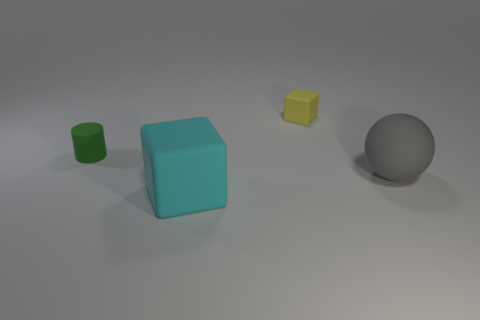Add 2 cyan cubes. How many objects exist? 6 Subtract all cylinders. How many objects are left? 3 Add 4 yellow matte cubes. How many yellow matte cubes exist? 5 Subtract 0 blue cylinders. How many objects are left? 4 Subtract all small blocks. Subtract all big cyan matte objects. How many objects are left? 2 Add 4 rubber cylinders. How many rubber cylinders are left? 5 